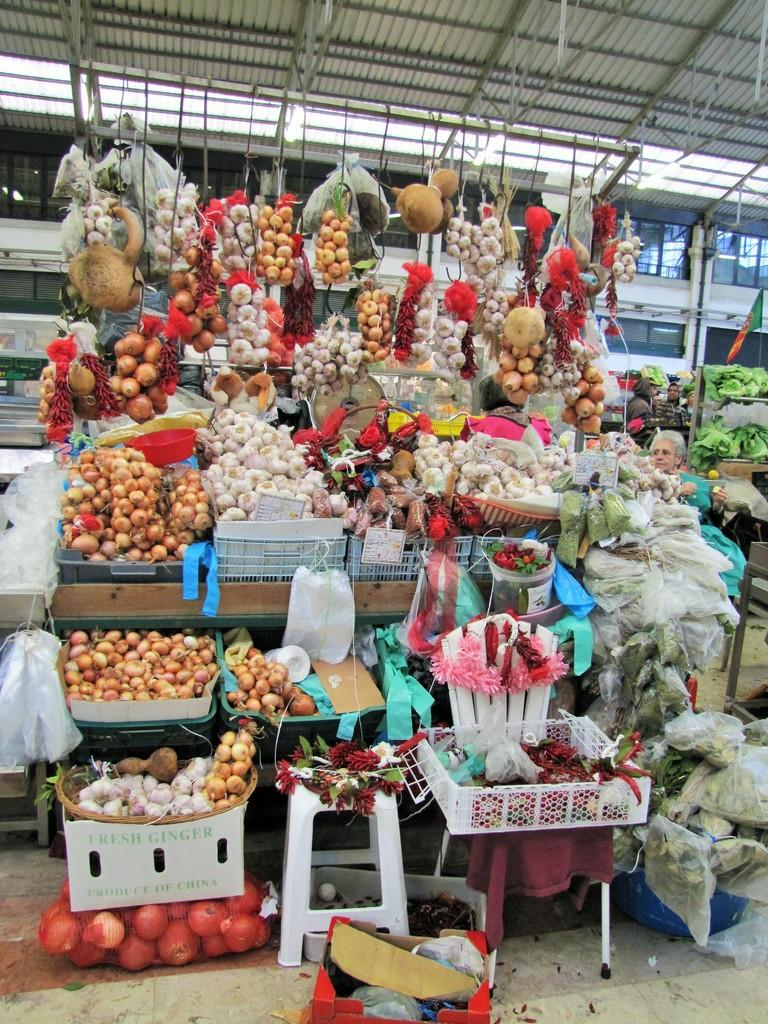What types of food can be seen in the image? There are fruits and vegetables on tables and baskets in the image. Can you describe the setting of the image? There is a person visible in the background of the image, and there is a roof in the image. What type of paper is the person holding in the image? There is no paper visible in the image; only fruits, vegetables, and a roof are present. 